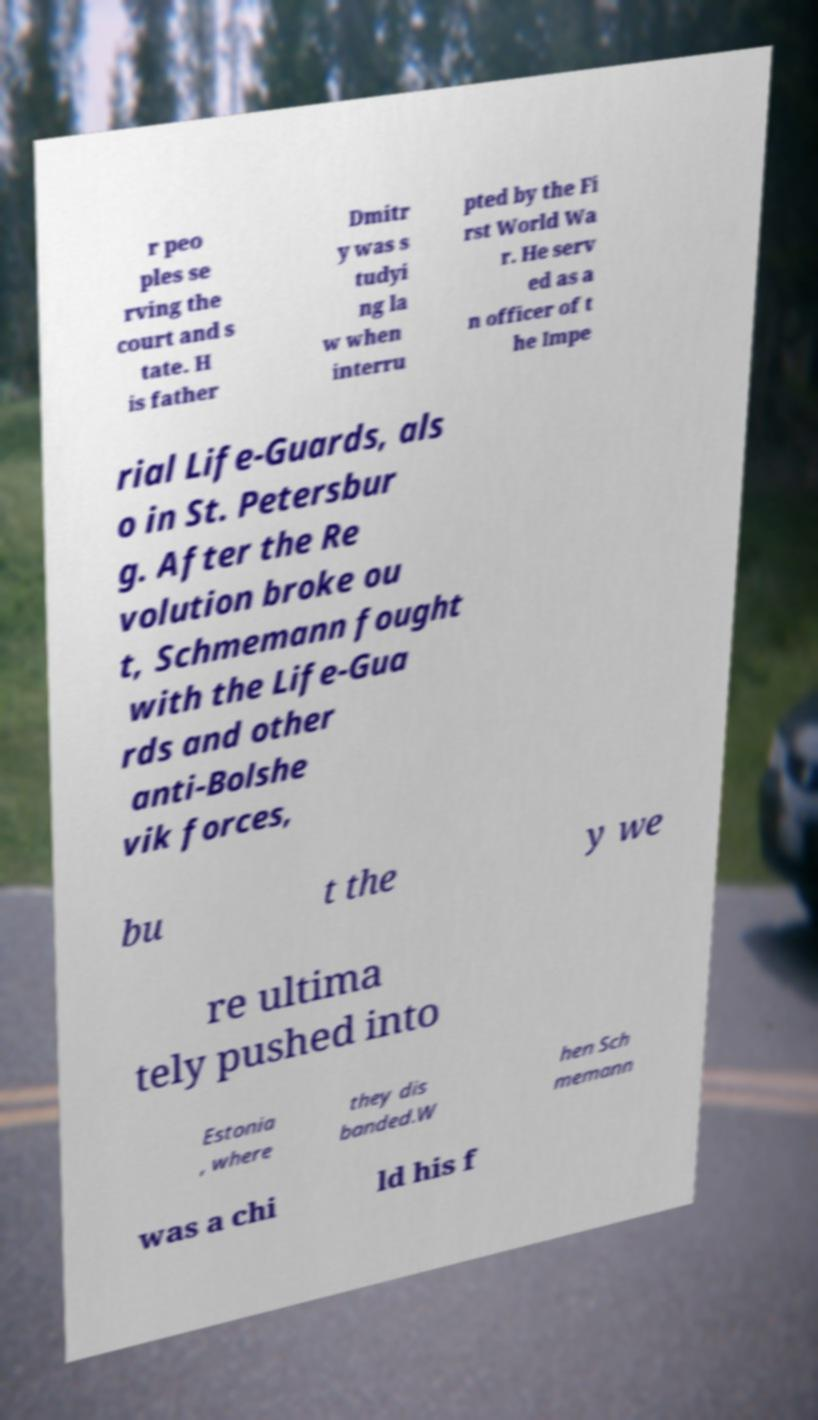What messages or text are displayed in this image? I need them in a readable, typed format. r peo ples se rving the court and s tate. H is father Dmitr y was s tudyi ng la w when interru pted by the Fi rst World Wa r. He serv ed as a n officer of t he Impe rial Life-Guards, als o in St. Petersbur g. After the Re volution broke ou t, Schmemann fought with the Life-Gua rds and other anti-Bolshe vik forces, bu t the y we re ultima tely pushed into Estonia , where they dis banded.W hen Sch memann was a chi ld his f 